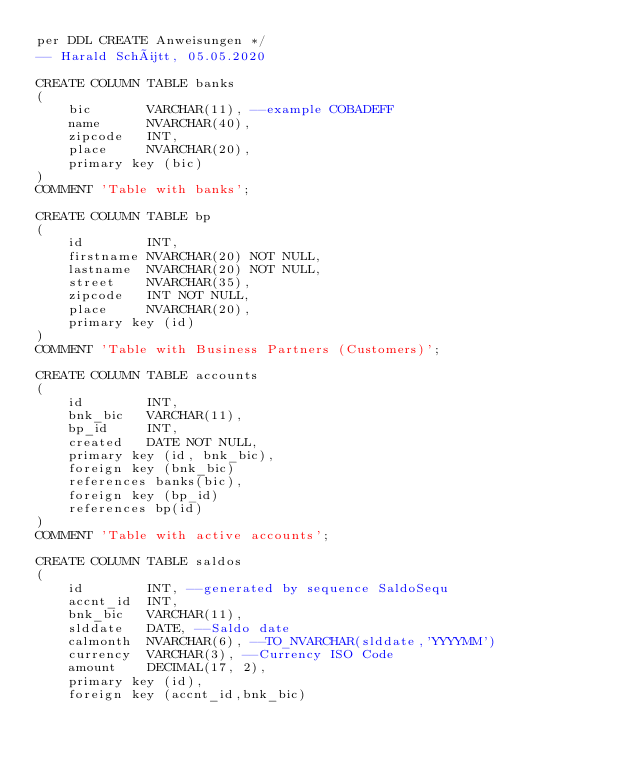Convert code to text. <code><loc_0><loc_0><loc_500><loc_500><_SQL_>per DDL CREATE Anweisungen */
-- Harald Schütt, 05.05.2020

CREATE COLUMN TABLE banks
(
	bic       VARCHAR(11), --example COBADEFF
	name      NVARCHAR(40),
	zipcode   INT,
    place     NVARCHAR(20),
	primary key (bic)
)
COMMENT 'Table with banks';

CREATE COLUMN TABLE bp
(
	id        INT, 
	firstname NVARCHAR(20) NOT NULL,
	lastname  NVARCHAR(20) NOT NULL,
	street    NVARCHAR(35),
    zipcode   INT NOT NULL,
    place     NVARCHAR(20),
	primary key (id)
)
COMMENT 'Table with Business Partners (Customers)';

CREATE COLUMN TABLE accounts
(
    id        INT, 
	bnk_bic   VARCHAR(11),
	bp_id	  INT,
	created   DATE NOT NULL,
	primary key (id, bnk_bic),
	foreign key (bnk_bic)
	references banks(bic),
	foreign key (bp_id)
	references bp(id)
)
COMMENT 'Table with active accounts';

CREATE COLUMN TABLE saldos
(
	id        INT, --generated by sequence SaldoSequ
	accnt_id  INT,
	bnk_bic   VARCHAR(11),
	slddate   DATE, --Saldo date
	calmonth  NVARCHAR(6), --TO_NVARCHAR(slddate,'YYYYMM')  
	currency  VARCHAR(3), --Currency ISO Code
	amount    DECIMAL(17, 2), 
	primary key (id),
	foreign key (accnt_id,bnk_bic)</code> 